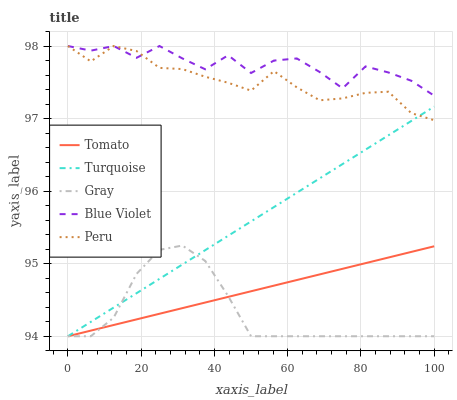Does Gray have the minimum area under the curve?
Answer yes or no. Yes. Does Blue Violet have the maximum area under the curve?
Answer yes or no. Yes. Does Turquoise have the minimum area under the curve?
Answer yes or no. No. Does Turquoise have the maximum area under the curve?
Answer yes or no. No. Is Tomato the smoothest?
Answer yes or no. Yes. Is Blue Violet the roughest?
Answer yes or no. Yes. Is Gray the smoothest?
Answer yes or no. No. Is Gray the roughest?
Answer yes or no. No. Does Tomato have the lowest value?
Answer yes or no. Yes. Does Peru have the lowest value?
Answer yes or no. No. Does Blue Violet have the highest value?
Answer yes or no. Yes. Does Gray have the highest value?
Answer yes or no. No. Is Turquoise less than Blue Violet?
Answer yes or no. Yes. Is Peru greater than Tomato?
Answer yes or no. Yes. Does Turquoise intersect Peru?
Answer yes or no. Yes. Is Turquoise less than Peru?
Answer yes or no. No. Is Turquoise greater than Peru?
Answer yes or no. No. Does Turquoise intersect Blue Violet?
Answer yes or no. No. 